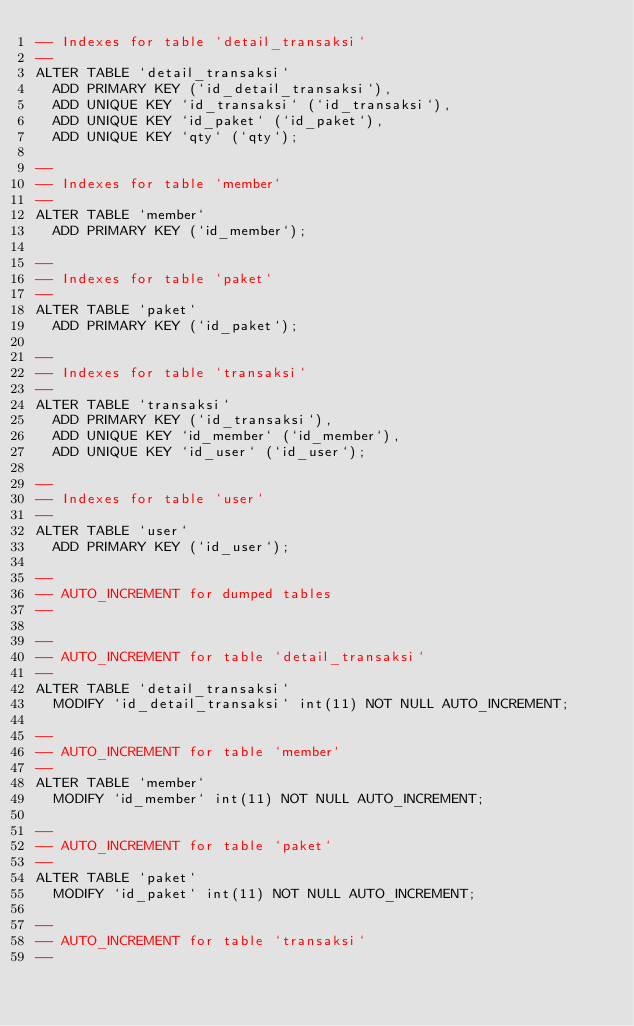<code> <loc_0><loc_0><loc_500><loc_500><_SQL_>-- Indexes for table `detail_transaksi`
--
ALTER TABLE `detail_transaksi`
  ADD PRIMARY KEY (`id_detail_transaksi`),
  ADD UNIQUE KEY `id_transaksi` (`id_transaksi`),
  ADD UNIQUE KEY `id_paket` (`id_paket`),
  ADD UNIQUE KEY `qty` (`qty`);

--
-- Indexes for table `member`
--
ALTER TABLE `member`
  ADD PRIMARY KEY (`id_member`);

--
-- Indexes for table `paket`
--
ALTER TABLE `paket`
  ADD PRIMARY KEY (`id_paket`);

--
-- Indexes for table `transaksi`
--
ALTER TABLE `transaksi`
  ADD PRIMARY KEY (`id_transaksi`),
  ADD UNIQUE KEY `id_member` (`id_member`),
  ADD UNIQUE KEY `id_user` (`id_user`);

--
-- Indexes for table `user`
--
ALTER TABLE `user`
  ADD PRIMARY KEY (`id_user`);

--
-- AUTO_INCREMENT for dumped tables
--

--
-- AUTO_INCREMENT for table `detail_transaksi`
--
ALTER TABLE `detail_transaksi`
  MODIFY `id_detail_transaksi` int(11) NOT NULL AUTO_INCREMENT;

--
-- AUTO_INCREMENT for table `member`
--
ALTER TABLE `member`
  MODIFY `id_member` int(11) NOT NULL AUTO_INCREMENT;

--
-- AUTO_INCREMENT for table `paket`
--
ALTER TABLE `paket`
  MODIFY `id_paket` int(11) NOT NULL AUTO_INCREMENT;

--
-- AUTO_INCREMENT for table `transaksi`
--</code> 